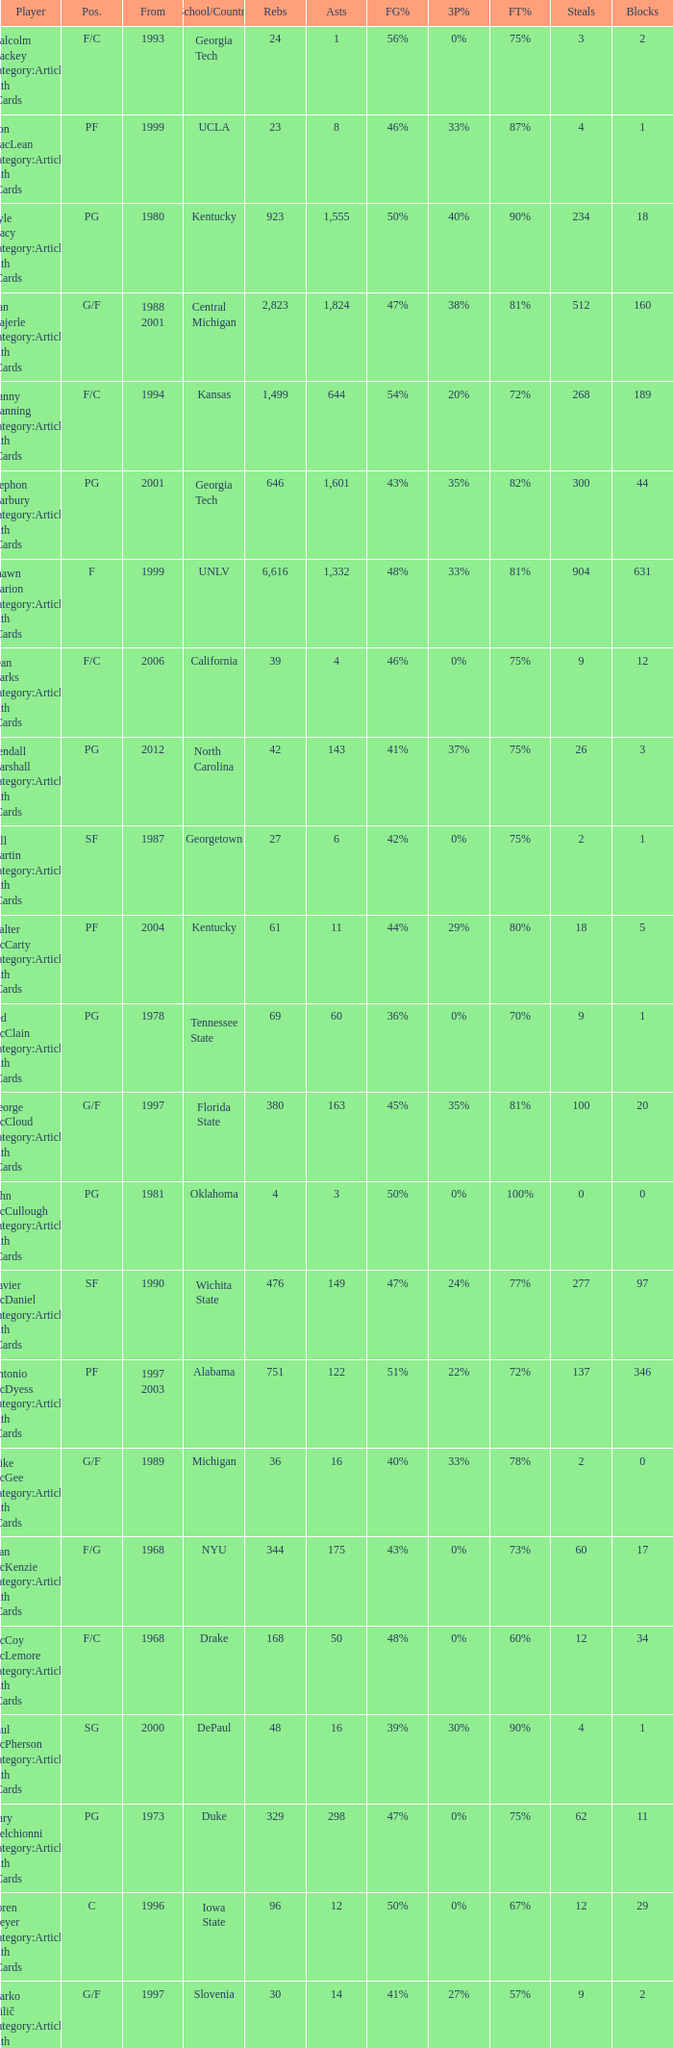Who has the high assists in 2000? 16.0. 